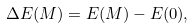Convert formula to latex. <formula><loc_0><loc_0><loc_500><loc_500>\Delta E ( M ) = E ( M ) - E ( 0 ) ,</formula> 